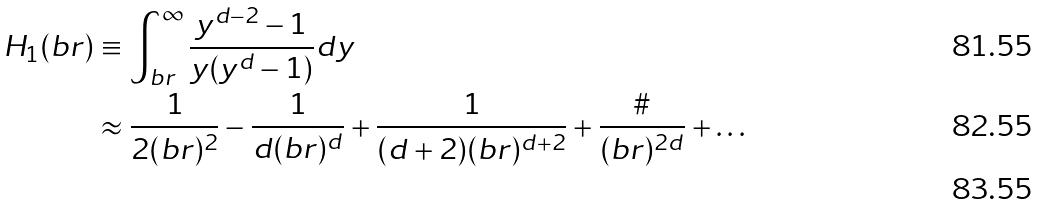Convert formula to latex. <formula><loc_0><loc_0><loc_500><loc_500>H _ { 1 } ( b r ) & \equiv \int _ { b r } ^ { \infty } \frac { y ^ { d - 2 } - 1 } { y ( y ^ { d } - 1 ) } d y \\ & \approx \frac { 1 } { 2 ( b r ) ^ { 2 } } - \frac { 1 } { d ( b r ) ^ { d } } + \frac { 1 } { ( d + 2 ) ( b r ) ^ { d + 2 } } + \frac { \# } { ( b r ) ^ { 2 d } } + \dots \\</formula> 